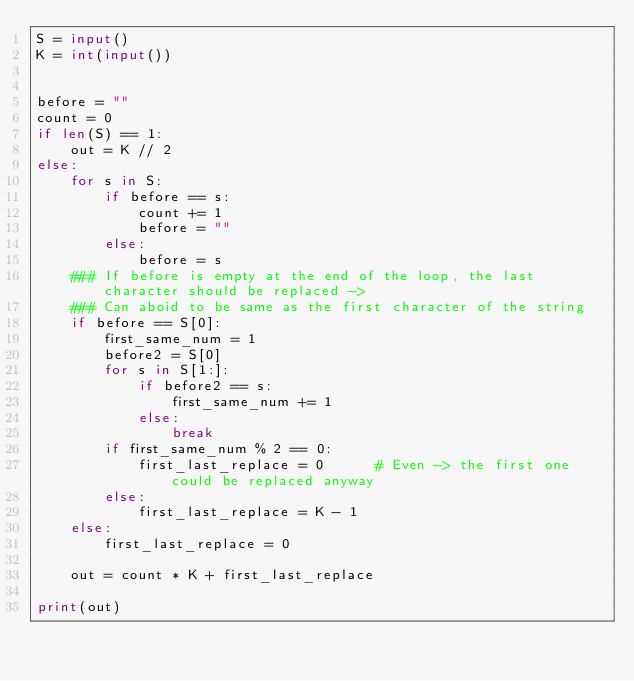<code> <loc_0><loc_0><loc_500><loc_500><_Python_>S = input()
K = int(input())


before = ""
count = 0
if len(S) == 1:
    out = K // 2
else:
    for s in S:
        if before == s:
            count += 1
            before = ""
        else:
            before = s
    ### If before is empty at the end of the loop, the last character should be replaced ->
    ### Can aboid to be same as the first character of the string
    if before == S[0]:
        first_same_num = 1
        before2 = S[0]
        for s in S[1:]:
            if before2 == s:
                first_same_num += 1
            else:
                break
        if first_same_num % 2 == 0:
            first_last_replace = 0      # Even -> the first one could be replaced anyway
        else:
            first_last_replace = K - 1
    else:
        first_last_replace = 0

    out = count * K + first_last_replace

print(out)
</code> 